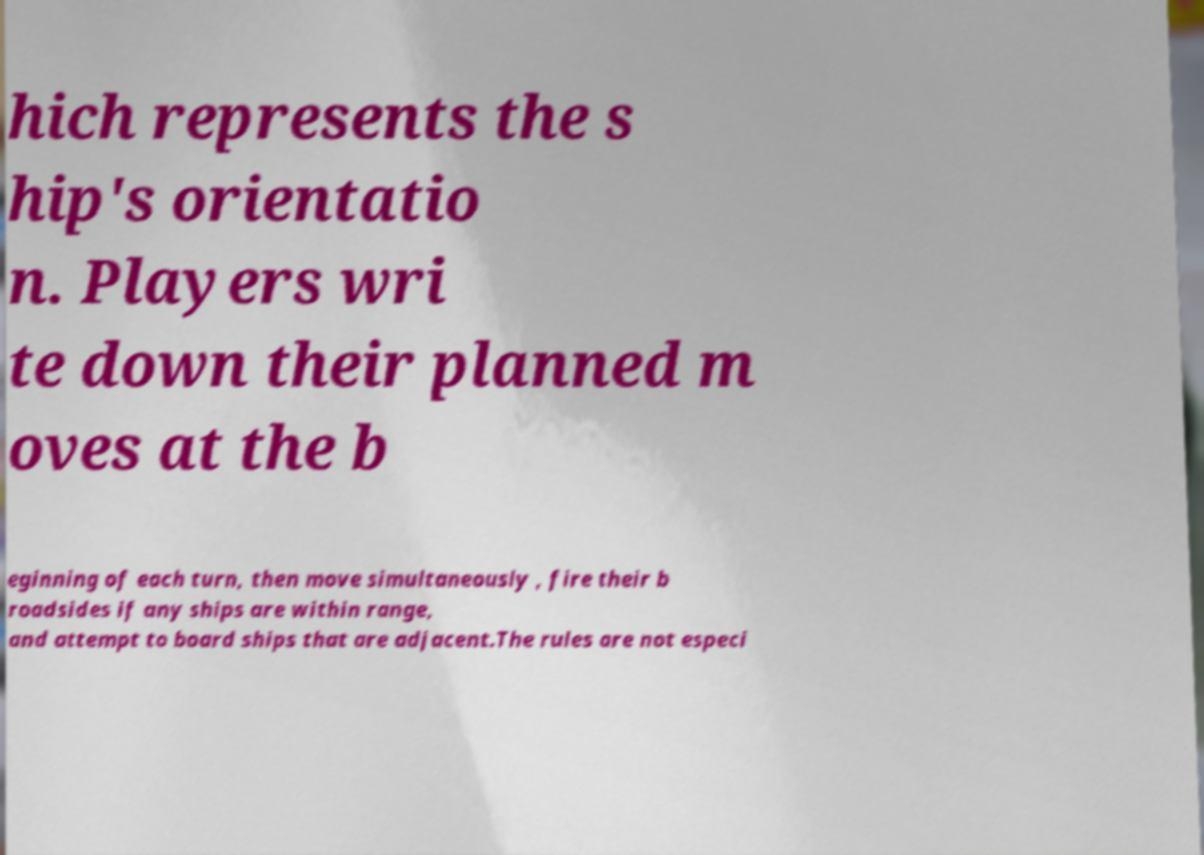Could you extract and type out the text from this image? hich represents the s hip's orientatio n. Players wri te down their planned m oves at the b eginning of each turn, then move simultaneously , fire their b roadsides if any ships are within range, and attempt to board ships that are adjacent.The rules are not especi 